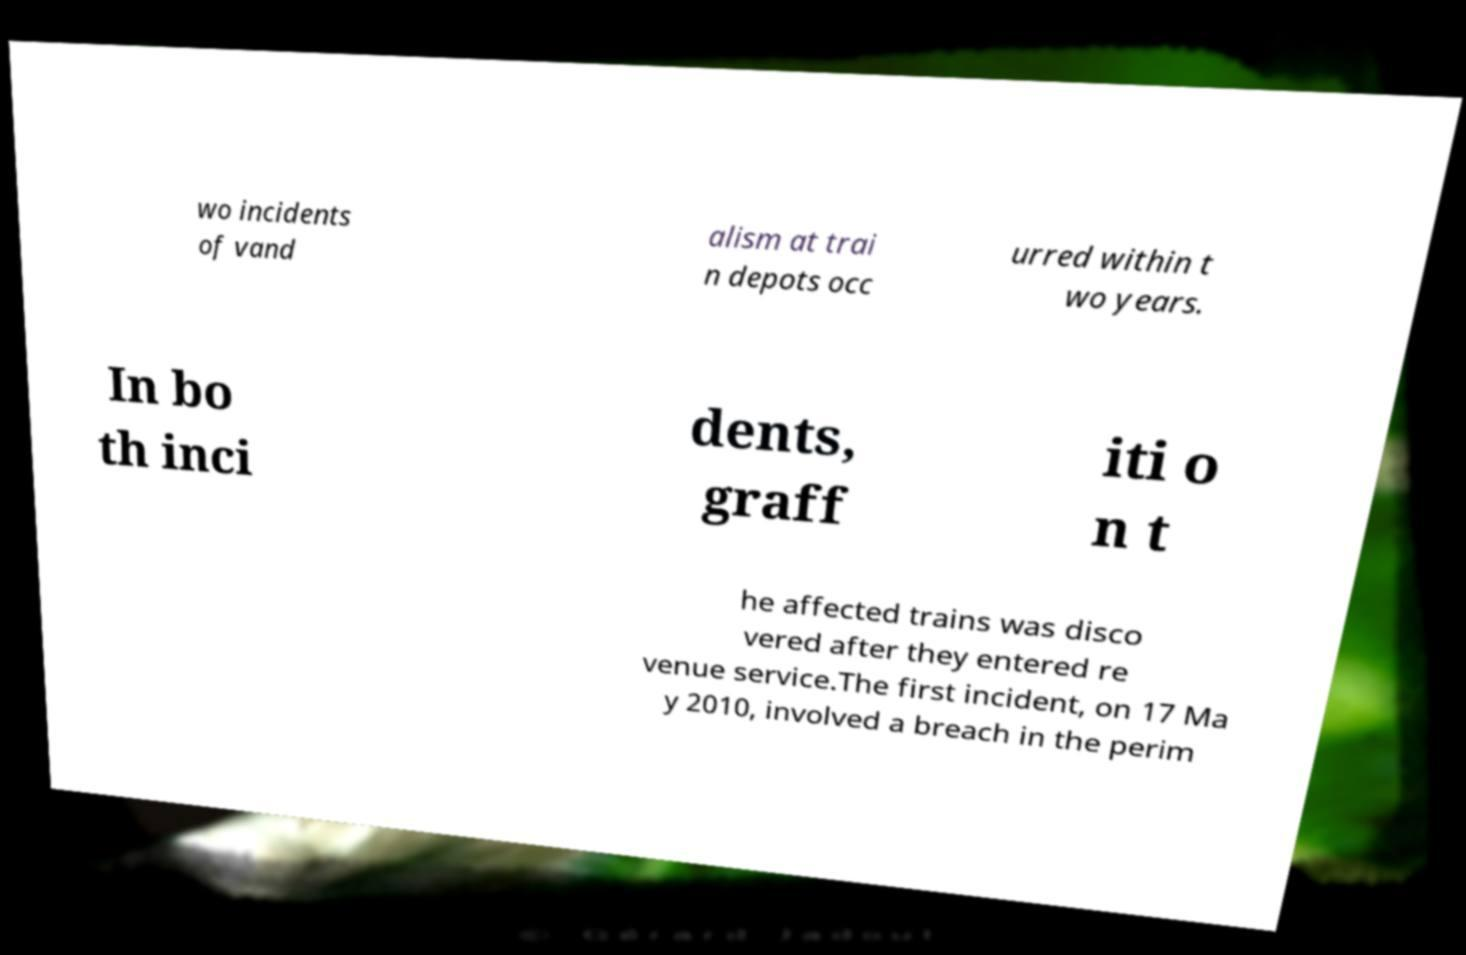Can you accurately transcribe the text from the provided image for me? wo incidents of vand alism at trai n depots occ urred within t wo years. In bo th inci dents, graff iti o n t he affected trains was disco vered after they entered re venue service.The first incident, on 17 Ma y 2010, involved a breach in the perim 